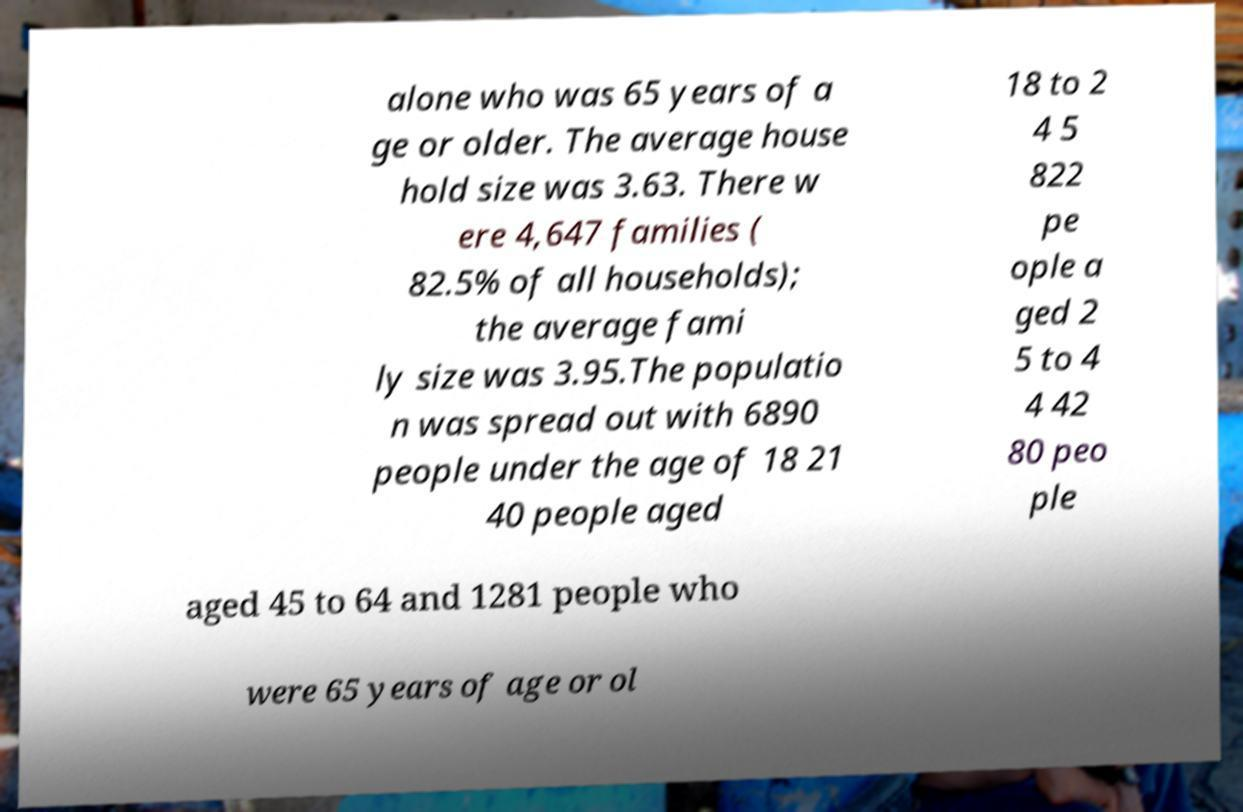Could you extract and type out the text from this image? alone who was 65 years of a ge or older. The average house hold size was 3.63. There w ere 4,647 families ( 82.5% of all households); the average fami ly size was 3.95.The populatio n was spread out with 6890 people under the age of 18 21 40 people aged 18 to 2 4 5 822 pe ople a ged 2 5 to 4 4 42 80 peo ple aged 45 to 64 and 1281 people who were 65 years of age or ol 